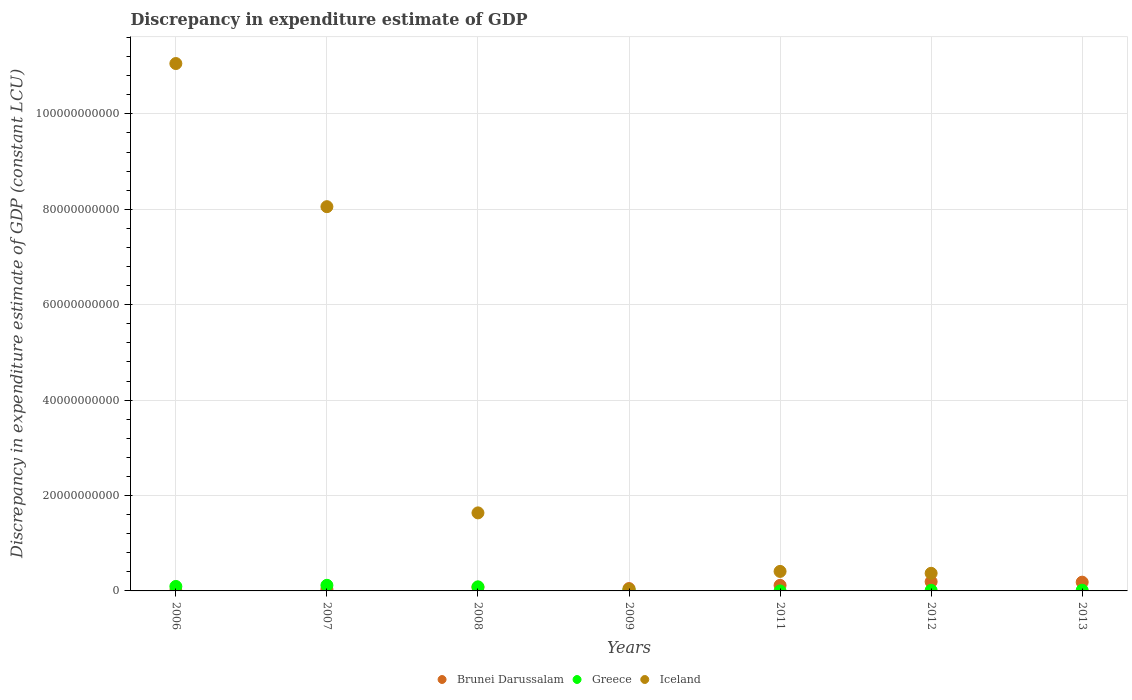What is the discrepancy in expenditure estimate of GDP in Brunei Darussalam in 2013?
Your answer should be very brief. 1.84e+09. Across all years, what is the maximum discrepancy in expenditure estimate of GDP in Iceland?
Offer a very short reply. 1.11e+11. Across all years, what is the minimum discrepancy in expenditure estimate of GDP in Iceland?
Offer a very short reply. 0. In which year was the discrepancy in expenditure estimate of GDP in Greece maximum?
Offer a very short reply. 2007. What is the total discrepancy in expenditure estimate of GDP in Brunei Darussalam in the graph?
Offer a very short reply. 6.58e+09. What is the difference between the discrepancy in expenditure estimate of GDP in Iceland in 2008 and that in 2011?
Provide a succinct answer. 1.23e+1. What is the difference between the discrepancy in expenditure estimate of GDP in Greece in 2007 and the discrepancy in expenditure estimate of GDP in Brunei Darussalam in 2009?
Ensure brevity in your answer.  6.81e+08. What is the average discrepancy in expenditure estimate of GDP in Brunei Darussalam per year?
Provide a short and direct response. 9.40e+08. In the year 2007, what is the difference between the discrepancy in expenditure estimate of GDP in Brunei Darussalam and discrepancy in expenditure estimate of GDP in Iceland?
Your answer should be very brief. -8.02e+1. In how many years, is the discrepancy in expenditure estimate of GDP in Greece greater than 12000000000 LCU?
Ensure brevity in your answer.  0. What is the ratio of the discrepancy in expenditure estimate of GDP in Greece in 2006 to that in 2011?
Give a very brief answer. 1.17e+06. Is the discrepancy in expenditure estimate of GDP in Greece in 2009 less than that in 2012?
Your answer should be compact. No. Is the difference between the discrepancy in expenditure estimate of GDP in Brunei Darussalam in 2009 and 2012 greater than the difference between the discrepancy in expenditure estimate of GDP in Iceland in 2009 and 2012?
Provide a short and direct response. Yes. What is the difference between the highest and the second highest discrepancy in expenditure estimate of GDP in Greece?
Provide a succinct answer. 2.37e+08. What is the difference between the highest and the lowest discrepancy in expenditure estimate of GDP in Greece?
Ensure brevity in your answer.  1.18e+09. In how many years, is the discrepancy in expenditure estimate of GDP in Brunei Darussalam greater than the average discrepancy in expenditure estimate of GDP in Brunei Darussalam taken over all years?
Offer a terse response. 3. Is the sum of the discrepancy in expenditure estimate of GDP in Brunei Darussalam in 2008 and 2011 greater than the maximum discrepancy in expenditure estimate of GDP in Iceland across all years?
Give a very brief answer. No. Does the discrepancy in expenditure estimate of GDP in Greece monotonically increase over the years?
Make the answer very short. No. How many years are there in the graph?
Ensure brevity in your answer.  7. What is the difference between two consecutive major ticks on the Y-axis?
Ensure brevity in your answer.  2.00e+1. Does the graph contain grids?
Your answer should be very brief. Yes. How are the legend labels stacked?
Your answer should be very brief. Horizontal. What is the title of the graph?
Ensure brevity in your answer.  Discrepancy in expenditure estimate of GDP. What is the label or title of the Y-axis?
Your response must be concise. Discrepancy in expenditure estimate of GDP (constant LCU). What is the Discrepancy in expenditure estimate of GDP (constant LCU) of Brunei Darussalam in 2006?
Keep it short and to the point. 3.53e+07. What is the Discrepancy in expenditure estimate of GDP (constant LCU) of Greece in 2006?
Your response must be concise. 9.39e+08. What is the Discrepancy in expenditure estimate of GDP (constant LCU) of Iceland in 2006?
Provide a short and direct response. 1.11e+11. What is the Discrepancy in expenditure estimate of GDP (constant LCU) in Brunei Darussalam in 2007?
Offer a terse response. 3.41e+08. What is the Discrepancy in expenditure estimate of GDP (constant LCU) of Greece in 2007?
Offer a terse response. 1.18e+09. What is the Discrepancy in expenditure estimate of GDP (constant LCU) in Iceland in 2007?
Make the answer very short. 8.05e+1. What is the Discrepancy in expenditure estimate of GDP (constant LCU) in Brunei Darussalam in 2008?
Keep it short and to the point. 7.68e+08. What is the Discrepancy in expenditure estimate of GDP (constant LCU) in Greece in 2008?
Offer a terse response. 8.52e+08. What is the Discrepancy in expenditure estimate of GDP (constant LCU) of Iceland in 2008?
Make the answer very short. 1.64e+1. What is the Discrepancy in expenditure estimate of GDP (constant LCU) of Brunei Darussalam in 2009?
Your response must be concise. 4.96e+08. What is the Discrepancy in expenditure estimate of GDP (constant LCU) in Greece in 2009?
Keep it short and to the point. 2.10e+08. What is the Discrepancy in expenditure estimate of GDP (constant LCU) in Iceland in 2009?
Provide a succinct answer. 3.02e+08. What is the Discrepancy in expenditure estimate of GDP (constant LCU) of Brunei Darussalam in 2011?
Your answer should be very brief. 1.17e+09. What is the Discrepancy in expenditure estimate of GDP (constant LCU) of Greece in 2011?
Your response must be concise. 800. What is the Discrepancy in expenditure estimate of GDP (constant LCU) in Iceland in 2011?
Keep it short and to the point. 4.09e+09. What is the Discrepancy in expenditure estimate of GDP (constant LCU) of Brunei Darussalam in 2012?
Offer a very short reply. 1.93e+09. What is the Discrepancy in expenditure estimate of GDP (constant LCU) in Greece in 2012?
Offer a terse response. 1.22e+08. What is the Discrepancy in expenditure estimate of GDP (constant LCU) of Iceland in 2012?
Your response must be concise. 3.69e+09. What is the Discrepancy in expenditure estimate of GDP (constant LCU) of Brunei Darussalam in 2013?
Offer a very short reply. 1.84e+09. What is the Discrepancy in expenditure estimate of GDP (constant LCU) in Greece in 2013?
Keep it short and to the point. 1.42e+08. What is the Discrepancy in expenditure estimate of GDP (constant LCU) in Iceland in 2013?
Your answer should be compact. 0. Across all years, what is the maximum Discrepancy in expenditure estimate of GDP (constant LCU) of Brunei Darussalam?
Ensure brevity in your answer.  1.93e+09. Across all years, what is the maximum Discrepancy in expenditure estimate of GDP (constant LCU) of Greece?
Provide a succinct answer. 1.18e+09. Across all years, what is the maximum Discrepancy in expenditure estimate of GDP (constant LCU) in Iceland?
Your response must be concise. 1.11e+11. Across all years, what is the minimum Discrepancy in expenditure estimate of GDP (constant LCU) of Brunei Darussalam?
Offer a terse response. 3.53e+07. Across all years, what is the minimum Discrepancy in expenditure estimate of GDP (constant LCU) in Greece?
Keep it short and to the point. 800. Across all years, what is the minimum Discrepancy in expenditure estimate of GDP (constant LCU) of Iceland?
Give a very brief answer. 0. What is the total Discrepancy in expenditure estimate of GDP (constant LCU) in Brunei Darussalam in the graph?
Keep it short and to the point. 6.58e+09. What is the total Discrepancy in expenditure estimate of GDP (constant LCU) in Greece in the graph?
Give a very brief answer. 3.44e+09. What is the total Discrepancy in expenditure estimate of GDP (constant LCU) of Iceland in the graph?
Your response must be concise. 2.16e+11. What is the difference between the Discrepancy in expenditure estimate of GDP (constant LCU) in Brunei Darussalam in 2006 and that in 2007?
Provide a succinct answer. -3.06e+08. What is the difference between the Discrepancy in expenditure estimate of GDP (constant LCU) in Greece in 2006 and that in 2007?
Keep it short and to the point. -2.37e+08. What is the difference between the Discrepancy in expenditure estimate of GDP (constant LCU) in Iceland in 2006 and that in 2007?
Your answer should be compact. 3.00e+1. What is the difference between the Discrepancy in expenditure estimate of GDP (constant LCU) in Brunei Darussalam in 2006 and that in 2008?
Make the answer very short. -7.33e+08. What is the difference between the Discrepancy in expenditure estimate of GDP (constant LCU) in Greece in 2006 and that in 2008?
Ensure brevity in your answer.  8.68e+07. What is the difference between the Discrepancy in expenditure estimate of GDP (constant LCU) of Iceland in 2006 and that in 2008?
Your answer should be compact. 9.42e+1. What is the difference between the Discrepancy in expenditure estimate of GDP (constant LCU) of Brunei Darussalam in 2006 and that in 2009?
Your response must be concise. -4.60e+08. What is the difference between the Discrepancy in expenditure estimate of GDP (constant LCU) in Greece in 2006 and that in 2009?
Give a very brief answer. 7.29e+08. What is the difference between the Discrepancy in expenditure estimate of GDP (constant LCU) of Iceland in 2006 and that in 2009?
Ensure brevity in your answer.  1.10e+11. What is the difference between the Discrepancy in expenditure estimate of GDP (constant LCU) of Brunei Darussalam in 2006 and that in 2011?
Offer a terse response. -1.13e+09. What is the difference between the Discrepancy in expenditure estimate of GDP (constant LCU) of Greece in 2006 and that in 2011?
Keep it short and to the point. 9.39e+08. What is the difference between the Discrepancy in expenditure estimate of GDP (constant LCU) in Iceland in 2006 and that in 2011?
Provide a succinct answer. 1.06e+11. What is the difference between the Discrepancy in expenditure estimate of GDP (constant LCU) in Brunei Darussalam in 2006 and that in 2012?
Ensure brevity in your answer.  -1.90e+09. What is the difference between the Discrepancy in expenditure estimate of GDP (constant LCU) of Greece in 2006 and that in 2012?
Keep it short and to the point. 8.18e+08. What is the difference between the Discrepancy in expenditure estimate of GDP (constant LCU) in Iceland in 2006 and that in 2012?
Keep it short and to the point. 1.07e+11. What is the difference between the Discrepancy in expenditure estimate of GDP (constant LCU) in Brunei Darussalam in 2006 and that in 2013?
Ensure brevity in your answer.  -1.80e+09. What is the difference between the Discrepancy in expenditure estimate of GDP (constant LCU) of Greece in 2006 and that in 2013?
Offer a terse response. 7.97e+08. What is the difference between the Discrepancy in expenditure estimate of GDP (constant LCU) of Brunei Darussalam in 2007 and that in 2008?
Your answer should be very brief. -4.27e+08. What is the difference between the Discrepancy in expenditure estimate of GDP (constant LCU) in Greece in 2007 and that in 2008?
Your response must be concise. 3.24e+08. What is the difference between the Discrepancy in expenditure estimate of GDP (constant LCU) in Iceland in 2007 and that in 2008?
Provide a short and direct response. 6.42e+1. What is the difference between the Discrepancy in expenditure estimate of GDP (constant LCU) of Brunei Darussalam in 2007 and that in 2009?
Your answer should be very brief. -1.55e+08. What is the difference between the Discrepancy in expenditure estimate of GDP (constant LCU) in Greece in 2007 and that in 2009?
Your response must be concise. 9.66e+08. What is the difference between the Discrepancy in expenditure estimate of GDP (constant LCU) in Iceland in 2007 and that in 2009?
Your response must be concise. 8.02e+1. What is the difference between the Discrepancy in expenditure estimate of GDP (constant LCU) of Brunei Darussalam in 2007 and that in 2011?
Make the answer very short. -8.28e+08. What is the difference between the Discrepancy in expenditure estimate of GDP (constant LCU) of Greece in 2007 and that in 2011?
Make the answer very short. 1.18e+09. What is the difference between the Discrepancy in expenditure estimate of GDP (constant LCU) of Iceland in 2007 and that in 2011?
Offer a terse response. 7.65e+1. What is the difference between the Discrepancy in expenditure estimate of GDP (constant LCU) in Brunei Darussalam in 2007 and that in 2012?
Make the answer very short. -1.59e+09. What is the difference between the Discrepancy in expenditure estimate of GDP (constant LCU) in Greece in 2007 and that in 2012?
Make the answer very short. 1.05e+09. What is the difference between the Discrepancy in expenditure estimate of GDP (constant LCU) in Iceland in 2007 and that in 2012?
Offer a terse response. 7.69e+1. What is the difference between the Discrepancy in expenditure estimate of GDP (constant LCU) in Brunei Darussalam in 2007 and that in 2013?
Your answer should be compact. -1.49e+09. What is the difference between the Discrepancy in expenditure estimate of GDP (constant LCU) of Greece in 2007 and that in 2013?
Your answer should be compact. 1.03e+09. What is the difference between the Discrepancy in expenditure estimate of GDP (constant LCU) of Brunei Darussalam in 2008 and that in 2009?
Make the answer very short. 2.72e+08. What is the difference between the Discrepancy in expenditure estimate of GDP (constant LCU) in Greece in 2008 and that in 2009?
Your answer should be very brief. 6.42e+08. What is the difference between the Discrepancy in expenditure estimate of GDP (constant LCU) in Iceland in 2008 and that in 2009?
Provide a short and direct response. 1.61e+1. What is the difference between the Discrepancy in expenditure estimate of GDP (constant LCU) of Brunei Darussalam in 2008 and that in 2011?
Provide a succinct answer. -4.01e+08. What is the difference between the Discrepancy in expenditure estimate of GDP (constant LCU) in Greece in 2008 and that in 2011?
Your answer should be very brief. 8.52e+08. What is the difference between the Discrepancy in expenditure estimate of GDP (constant LCU) in Iceland in 2008 and that in 2011?
Your answer should be compact. 1.23e+1. What is the difference between the Discrepancy in expenditure estimate of GDP (constant LCU) in Brunei Darussalam in 2008 and that in 2012?
Your answer should be very brief. -1.17e+09. What is the difference between the Discrepancy in expenditure estimate of GDP (constant LCU) of Greece in 2008 and that in 2012?
Keep it short and to the point. 7.31e+08. What is the difference between the Discrepancy in expenditure estimate of GDP (constant LCU) in Iceland in 2008 and that in 2012?
Offer a terse response. 1.27e+1. What is the difference between the Discrepancy in expenditure estimate of GDP (constant LCU) in Brunei Darussalam in 2008 and that in 2013?
Provide a short and direct response. -1.07e+09. What is the difference between the Discrepancy in expenditure estimate of GDP (constant LCU) in Greece in 2008 and that in 2013?
Your answer should be compact. 7.10e+08. What is the difference between the Discrepancy in expenditure estimate of GDP (constant LCU) in Brunei Darussalam in 2009 and that in 2011?
Give a very brief answer. -6.73e+08. What is the difference between the Discrepancy in expenditure estimate of GDP (constant LCU) in Greece in 2009 and that in 2011?
Your response must be concise. 2.10e+08. What is the difference between the Discrepancy in expenditure estimate of GDP (constant LCU) in Iceland in 2009 and that in 2011?
Your answer should be very brief. -3.79e+09. What is the difference between the Discrepancy in expenditure estimate of GDP (constant LCU) in Brunei Darussalam in 2009 and that in 2012?
Provide a short and direct response. -1.44e+09. What is the difference between the Discrepancy in expenditure estimate of GDP (constant LCU) in Greece in 2009 and that in 2012?
Your answer should be very brief. 8.82e+07. What is the difference between the Discrepancy in expenditure estimate of GDP (constant LCU) of Iceland in 2009 and that in 2012?
Provide a short and direct response. -3.39e+09. What is the difference between the Discrepancy in expenditure estimate of GDP (constant LCU) in Brunei Darussalam in 2009 and that in 2013?
Ensure brevity in your answer.  -1.34e+09. What is the difference between the Discrepancy in expenditure estimate of GDP (constant LCU) of Greece in 2009 and that in 2013?
Keep it short and to the point. 6.77e+07. What is the difference between the Discrepancy in expenditure estimate of GDP (constant LCU) of Brunei Darussalam in 2011 and that in 2012?
Keep it short and to the point. -7.64e+08. What is the difference between the Discrepancy in expenditure estimate of GDP (constant LCU) in Greece in 2011 and that in 2012?
Ensure brevity in your answer.  -1.22e+08. What is the difference between the Discrepancy in expenditure estimate of GDP (constant LCU) of Iceland in 2011 and that in 2012?
Keep it short and to the point. 3.97e+08. What is the difference between the Discrepancy in expenditure estimate of GDP (constant LCU) in Brunei Darussalam in 2011 and that in 2013?
Offer a very short reply. -6.67e+08. What is the difference between the Discrepancy in expenditure estimate of GDP (constant LCU) of Greece in 2011 and that in 2013?
Your answer should be very brief. -1.42e+08. What is the difference between the Discrepancy in expenditure estimate of GDP (constant LCU) in Brunei Darussalam in 2012 and that in 2013?
Your answer should be very brief. 9.79e+07. What is the difference between the Discrepancy in expenditure estimate of GDP (constant LCU) in Greece in 2012 and that in 2013?
Your answer should be very brief. -2.05e+07. What is the difference between the Discrepancy in expenditure estimate of GDP (constant LCU) of Brunei Darussalam in 2006 and the Discrepancy in expenditure estimate of GDP (constant LCU) of Greece in 2007?
Provide a short and direct response. -1.14e+09. What is the difference between the Discrepancy in expenditure estimate of GDP (constant LCU) in Brunei Darussalam in 2006 and the Discrepancy in expenditure estimate of GDP (constant LCU) in Iceland in 2007?
Give a very brief answer. -8.05e+1. What is the difference between the Discrepancy in expenditure estimate of GDP (constant LCU) in Greece in 2006 and the Discrepancy in expenditure estimate of GDP (constant LCU) in Iceland in 2007?
Ensure brevity in your answer.  -7.96e+1. What is the difference between the Discrepancy in expenditure estimate of GDP (constant LCU) of Brunei Darussalam in 2006 and the Discrepancy in expenditure estimate of GDP (constant LCU) of Greece in 2008?
Keep it short and to the point. -8.17e+08. What is the difference between the Discrepancy in expenditure estimate of GDP (constant LCU) in Brunei Darussalam in 2006 and the Discrepancy in expenditure estimate of GDP (constant LCU) in Iceland in 2008?
Offer a very short reply. -1.63e+1. What is the difference between the Discrepancy in expenditure estimate of GDP (constant LCU) of Greece in 2006 and the Discrepancy in expenditure estimate of GDP (constant LCU) of Iceland in 2008?
Offer a very short reply. -1.54e+1. What is the difference between the Discrepancy in expenditure estimate of GDP (constant LCU) in Brunei Darussalam in 2006 and the Discrepancy in expenditure estimate of GDP (constant LCU) in Greece in 2009?
Ensure brevity in your answer.  -1.75e+08. What is the difference between the Discrepancy in expenditure estimate of GDP (constant LCU) of Brunei Darussalam in 2006 and the Discrepancy in expenditure estimate of GDP (constant LCU) of Iceland in 2009?
Your answer should be very brief. -2.67e+08. What is the difference between the Discrepancy in expenditure estimate of GDP (constant LCU) of Greece in 2006 and the Discrepancy in expenditure estimate of GDP (constant LCU) of Iceland in 2009?
Offer a terse response. 6.37e+08. What is the difference between the Discrepancy in expenditure estimate of GDP (constant LCU) of Brunei Darussalam in 2006 and the Discrepancy in expenditure estimate of GDP (constant LCU) of Greece in 2011?
Offer a very short reply. 3.53e+07. What is the difference between the Discrepancy in expenditure estimate of GDP (constant LCU) in Brunei Darussalam in 2006 and the Discrepancy in expenditure estimate of GDP (constant LCU) in Iceland in 2011?
Ensure brevity in your answer.  -4.05e+09. What is the difference between the Discrepancy in expenditure estimate of GDP (constant LCU) in Greece in 2006 and the Discrepancy in expenditure estimate of GDP (constant LCU) in Iceland in 2011?
Provide a succinct answer. -3.15e+09. What is the difference between the Discrepancy in expenditure estimate of GDP (constant LCU) in Brunei Darussalam in 2006 and the Discrepancy in expenditure estimate of GDP (constant LCU) in Greece in 2012?
Ensure brevity in your answer.  -8.65e+07. What is the difference between the Discrepancy in expenditure estimate of GDP (constant LCU) of Brunei Darussalam in 2006 and the Discrepancy in expenditure estimate of GDP (constant LCU) of Iceland in 2012?
Give a very brief answer. -3.66e+09. What is the difference between the Discrepancy in expenditure estimate of GDP (constant LCU) of Greece in 2006 and the Discrepancy in expenditure estimate of GDP (constant LCU) of Iceland in 2012?
Your answer should be compact. -2.75e+09. What is the difference between the Discrepancy in expenditure estimate of GDP (constant LCU) in Brunei Darussalam in 2006 and the Discrepancy in expenditure estimate of GDP (constant LCU) in Greece in 2013?
Provide a short and direct response. -1.07e+08. What is the difference between the Discrepancy in expenditure estimate of GDP (constant LCU) of Brunei Darussalam in 2007 and the Discrepancy in expenditure estimate of GDP (constant LCU) of Greece in 2008?
Offer a terse response. -5.12e+08. What is the difference between the Discrepancy in expenditure estimate of GDP (constant LCU) of Brunei Darussalam in 2007 and the Discrepancy in expenditure estimate of GDP (constant LCU) of Iceland in 2008?
Give a very brief answer. -1.60e+1. What is the difference between the Discrepancy in expenditure estimate of GDP (constant LCU) of Greece in 2007 and the Discrepancy in expenditure estimate of GDP (constant LCU) of Iceland in 2008?
Provide a succinct answer. -1.52e+1. What is the difference between the Discrepancy in expenditure estimate of GDP (constant LCU) in Brunei Darussalam in 2007 and the Discrepancy in expenditure estimate of GDP (constant LCU) in Greece in 2009?
Offer a very short reply. 1.31e+08. What is the difference between the Discrepancy in expenditure estimate of GDP (constant LCU) in Brunei Darussalam in 2007 and the Discrepancy in expenditure estimate of GDP (constant LCU) in Iceland in 2009?
Offer a terse response. 3.87e+07. What is the difference between the Discrepancy in expenditure estimate of GDP (constant LCU) of Greece in 2007 and the Discrepancy in expenditure estimate of GDP (constant LCU) of Iceland in 2009?
Offer a very short reply. 8.74e+08. What is the difference between the Discrepancy in expenditure estimate of GDP (constant LCU) of Brunei Darussalam in 2007 and the Discrepancy in expenditure estimate of GDP (constant LCU) of Greece in 2011?
Keep it short and to the point. 3.41e+08. What is the difference between the Discrepancy in expenditure estimate of GDP (constant LCU) of Brunei Darussalam in 2007 and the Discrepancy in expenditure estimate of GDP (constant LCU) of Iceland in 2011?
Keep it short and to the point. -3.75e+09. What is the difference between the Discrepancy in expenditure estimate of GDP (constant LCU) in Greece in 2007 and the Discrepancy in expenditure estimate of GDP (constant LCU) in Iceland in 2011?
Offer a very short reply. -2.91e+09. What is the difference between the Discrepancy in expenditure estimate of GDP (constant LCU) in Brunei Darussalam in 2007 and the Discrepancy in expenditure estimate of GDP (constant LCU) in Greece in 2012?
Provide a succinct answer. 2.19e+08. What is the difference between the Discrepancy in expenditure estimate of GDP (constant LCU) in Brunei Darussalam in 2007 and the Discrepancy in expenditure estimate of GDP (constant LCU) in Iceland in 2012?
Keep it short and to the point. -3.35e+09. What is the difference between the Discrepancy in expenditure estimate of GDP (constant LCU) in Greece in 2007 and the Discrepancy in expenditure estimate of GDP (constant LCU) in Iceland in 2012?
Offer a very short reply. -2.52e+09. What is the difference between the Discrepancy in expenditure estimate of GDP (constant LCU) in Brunei Darussalam in 2007 and the Discrepancy in expenditure estimate of GDP (constant LCU) in Greece in 2013?
Provide a succinct answer. 1.98e+08. What is the difference between the Discrepancy in expenditure estimate of GDP (constant LCU) of Brunei Darussalam in 2008 and the Discrepancy in expenditure estimate of GDP (constant LCU) of Greece in 2009?
Provide a short and direct response. 5.58e+08. What is the difference between the Discrepancy in expenditure estimate of GDP (constant LCU) of Brunei Darussalam in 2008 and the Discrepancy in expenditure estimate of GDP (constant LCU) of Iceland in 2009?
Provide a succinct answer. 4.66e+08. What is the difference between the Discrepancy in expenditure estimate of GDP (constant LCU) of Greece in 2008 and the Discrepancy in expenditure estimate of GDP (constant LCU) of Iceland in 2009?
Keep it short and to the point. 5.50e+08. What is the difference between the Discrepancy in expenditure estimate of GDP (constant LCU) of Brunei Darussalam in 2008 and the Discrepancy in expenditure estimate of GDP (constant LCU) of Greece in 2011?
Offer a very short reply. 7.68e+08. What is the difference between the Discrepancy in expenditure estimate of GDP (constant LCU) in Brunei Darussalam in 2008 and the Discrepancy in expenditure estimate of GDP (constant LCU) in Iceland in 2011?
Keep it short and to the point. -3.32e+09. What is the difference between the Discrepancy in expenditure estimate of GDP (constant LCU) of Greece in 2008 and the Discrepancy in expenditure estimate of GDP (constant LCU) of Iceland in 2011?
Your answer should be compact. -3.24e+09. What is the difference between the Discrepancy in expenditure estimate of GDP (constant LCU) of Brunei Darussalam in 2008 and the Discrepancy in expenditure estimate of GDP (constant LCU) of Greece in 2012?
Offer a very short reply. 6.46e+08. What is the difference between the Discrepancy in expenditure estimate of GDP (constant LCU) in Brunei Darussalam in 2008 and the Discrepancy in expenditure estimate of GDP (constant LCU) in Iceland in 2012?
Ensure brevity in your answer.  -2.93e+09. What is the difference between the Discrepancy in expenditure estimate of GDP (constant LCU) in Greece in 2008 and the Discrepancy in expenditure estimate of GDP (constant LCU) in Iceland in 2012?
Make the answer very short. -2.84e+09. What is the difference between the Discrepancy in expenditure estimate of GDP (constant LCU) of Brunei Darussalam in 2008 and the Discrepancy in expenditure estimate of GDP (constant LCU) of Greece in 2013?
Provide a succinct answer. 6.26e+08. What is the difference between the Discrepancy in expenditure estimate of GDP (constant LCU) of Brunei Darussalam in 2009 and the Discrepancy in expenditure estimate of GDP (constant LCU) of Greece in 2011?
Make the answer very short. 4.95e+08. What is the difference between the Discrepancy in expenditure estimate of GDP (constant LCU) of Brunei Darussalam in 2009 and the Discrepancy in expenditure estimate of GDP (constant LCU) of Iceland in 2011?
Your response must be concise. -3.59e+09. What is the difference between the Discrepancy in expenditure estimate of GDP (constant LCU) in Greece in 2009 and the Discrepancy in expenditure estimate of GDP (constant LCU) in Iceland in 2011?
Provide a succinct answer. -3.88e+09. What is the difference between the Discrepancy in expenditure estimate of GDP (constant LCU) in Brunei Darussalam in 2009 and the Discrepancy in expenditure estimate of GDP (constant LCU) in Greece in 2012?
Ensure brevity in your answer.  3.74e+08. What is the difference between the Discrepancy in expenditure estimate of GDP (constant LCU) in Brunei Darussalam in 2009 and the Discrepancy in expenditure estimate of GDP (constant LCU) in Iceland in 2012?
Provide a succinct answer. -3.20e+09. What is the difference between the Discrepancy in expenditure estimate of GDP (constant LCU) in Greece in 2009 and the Discrepancy in expenditure estimate of GDP (constant LCU) in Iceland in 2012?
Give a very brief answer. -3.48e+09. What is the difference between the Discrepancy in expenditure estimate of GDP (constant LCU) in Brunei Darussalam in 2009 and the Discrepancy in expenditure estimate of GDP (constant LCU) in Greece in 2013?
Provide a short and direct response. 3.53e+08. What is the difference between the Discrepancy in expenditure estimate of GDP (constant LCU) of Brunei Darussalam in 2011 and the Discrepancy in expenditure estimate of GDP (constant LCU) of Greece in 2012?
Ensure brevity in your answer.  1.05e+09. What is the difference between the Discrepancy in expenditure estimate of GDP (constant LCU) of Brunei Darussalam in 2011 and the Discrepancy in expenditure estimate of GDP (constant LCU) of Iceland in 2012?
Provide a short and direct response. -2.52e+09. What is the difference between the Discrepancy in expenditure estimate of GDP (constant LCU) in Greece in 2011 and the Discrepancy in expenditure estimate of GDP (constant LCU) in Iceland in 2012?
Your answer should be very brief. -3.69e+09. What is the difference between the Discrepancy in expenditure estimate of GDP (constant LCU) in Brunei Darussalam in 2011 and the Discrepancy in expenditure estimate of GDP (constant LCU) in Greece in 2013?
Your answer should be very brief. 1.03e+09. What is the difference between the Discrepancy in expenditure estimate of GDP (constant LCU) of Brunei Darussalam in 2012 and the Discrepancy in expenditure estimate of GDP (constant LCU) of Greece in 2013?
Your answer should be compact. 1.79e+09. What is the average Discrepancy in expenditure estimate of GDP (constant LCU) of Brunei Darussalam per year?
Your answer should be compact. 9.40e+08. What is the average Discrepancy in expenditure estimate of GDP (constant LCU) in Greece per year?
Give a very brief answer. 4.92e+08. What is the average Discrepancy in expenditure estimate of GDP (constant LCU) of Iceland per year?
Make the answer very short. 3.08e+1. In the year 2006, what is the difference between the Discrepancy in expenditure estimate of GDP (constant LCU) in Brunei Darussalam and Discrepancy in expenditure estimate of GDP (constant LCU) in Greece?
Ensure brevity in your answer.  -9.04e+08. In the year 2006, what is the difference between the Discrepancy in expenditure estimate of GDP (constant LCU) in Brunei Darussalam and Discrepancy in expenditure estimate of GDP (constant LCU) in Iceland?
Ensure brevity in your answer.  -1.11e+11. In the year 2006, what is the difference between the Discrepancy in expenditure estimate of GDP (constant LCU) in Greece and Discrepancy in expenditure estimate of GDP (constant LCU) in Iceland?
Ensure brevity in your answer.  -1.10e+11. In the year 2007, what is the difference between the Discrepancy in expenditure estimate of GDP (constant LCU) in Brunei Darussalam and Discrepancy in expenditure estimate of GDP (constant LCU) in Greece?
Make the answer very short. -8.35e+08. In the year 2007, what is the difference between the Discrepancy in expenditure estimate of GDP (constant LCU) of Brunei Darussalam and Discrepancy in expenditure estimate of GDP (constant LCU) of Iceland?
Your answer should be very brief. -8.02e+1. In the year 2007, what is the difference between the Discrepancy in expenditure estimate of GDP (constant LCU) in Greece and Discrepancy in expenditure estimate of GDP (constant LCU) in Iceland?
Your response must be concise. -7.94e+1. In the year 2008, what is the difference between the Discrepancy in expenditure estimate of GDP (constant LCU) in Brunei Darussalam and Discrepancy in expenditure estimate of GDP (constant LCU) in Greece?
Give a very brief answer. -8.45e+07. In the year 2008, what is the difference between the Discrepancy in expenditure estimate of GDP (constant LCU) of Brunei Darussalam and Discrepancy in expenditure estimate of GDP (constant LCU) of Iceland?
Your answer should be compact. -1.56e+1. In the year 2008, what is the difference between the Discrepancy in expenditure estimate of GDP (constant LCU) of Greece and Discrepancy in expenditure estimate of GDP (constant LCU) of Iceland?
Offer a very short reply. -1.55e+1. In the year 2009, what is the difference between the Discrepancy in expenditure estimate of GDP (constant LCU) in Brunei Darussalam and Discrepancy in expenditure estimate of GDP (constant LCU) in Greece?
Keep it short and to the point. 2.85e+08. In the year 2009, what is the difference between the Discrepancy in expenditure estimate of GDP (constant LCU) in Brunei Darussalam and Discrepancy in expenditure estimate of GDP (constant LCU) in Iceland?
Make the answer very short. 1.93e+08. In the year 2009, what is the difference between the Discrepancy in expenditure estimate of GDP (constant LCU) in Greece and Discrepancy in expenditure estimate of GDP (constant LCU) in Iceland?
Provide a short and direct response. -9.21e+07. In the year 2011, what is the difference between the Discrepancy in expenditure estimate of GDP (constant LCU) in Brunei Darussalam and Discrepancy in expenditure estimate of GDP (constant LCU) in Greece?
Your response must be concise. 1.17e+09. In the year 2011, what is the difference between the Discrepancy in expenditure estimate of GDP (constant LCU) of Brunei Darussalam and Discrepancy in expenditure estimate of GDP (constant LCU) of Iceland?
Offer a terse response. -2.92e+09. In the year 2011, what is the difference between the Discrepancy in expenditure estimate of GDP (constant LCU) in Greece and Discrepancy in expenditure estimate of GDP (constant LCU) in Iceland?
Provide a short and direct response. -4.09e+09. In the year 2012, what is the difference between the Discrepancy in expenditure estimate of GDP (constant LCU) in Brunei Darussalam and Discrepancy in expenditure estimate of GDP (constant LCU) in Greece?
Keep it short and to the point. 1.81e+09. In the year 2012, what is the difference between the Discrepancy in expenditure estimate of GDP (constant LCU) in Brunei Darussalam and Discrepancy in expenditure estimate of GDP (constant LCU) in Iceland?
Give a very brief answer. -1.76e+09. In the year 2012, what is the difference between the Discrepancy in expenditure estimate of GDP (constant LCU) of Greece and Discrepancy in expenditure estimate of GDP (constant LCU) of Iceland?
Offer a terse response. -3.57e+09. In the year 2013, what is the difference between the Discrepancy in expenditure estimate of GDP (constant LCU) in Brunei Darussalam and Discrepancy in expenditure estimate of GDP (constant LCU) in Greece?
Your answer should be very brief. 1.69e+09. What is the ratio of the Discrepancy in expenditure estimate of GDP (constant LCU) in Brunei Darussalam in 2006 to that in 2007?
Provide a succinct answer. 0.1. What is the ratio of the Discrepancy in expenditure estimate of GDP (constant LCU) of Greece in 2006 to that in 2007?
Your answer should be very brief. 0.8. What is the ratio of the Discrepancy in expenditure estimate of GDP (constant LCU) of Iceland in 2006 to that in 2007?
Offer a terse response. 1.37. What is the ratio of the Discrepancy in expenditure estimate of GDP (constant LCU) in Brunei Darussalam in 2006 to that in 2008?
Your response must be concise. 0.05. What is the ratio of the Discrepancy in expenditure estimate of GDP (constant LCU) of Greece in 2006 to that in 2008?
Your answer should be compact. 1.1. What is the ratio of the Discrepancy in expenditure estimate of GDP (constant LCU) in Iceland in 2006 to that in 2008?
Provide a short and direct response. 6.76. What is the ratio of the Discrepancy in expenditure estimate of GDP (constant LCU) of Brunei Darussalam in 2006 to that in 2009?
Offer a terse response. 0.07. What is the ratio of the Discrepancy in expenditure estimate of GDP (constant LCU) of Greece in 2006 to that in 2009?
Your response must be concise. 4.47. What is the ratio of the Discrepancy in expenditure estimate of GDP (constant LCU) in Iceland in 2006 to that in 2009?
Your response must be concise. 365.89. What is the ratio of the Discrepancy in expenditure estimate of GDP (constant LCU) in Brunei Darussalam in 2006 to that in 2011?
Your answer should be very brief. 0.03. What is the ratio of the Discrepancy in expenditure estimate of GDP (constant LCU) of Greece in 2006 to that in 2011?
Offer a very short reply. 1.17e+06. What is the ratio of the Discrepancy in expenditure estimate of GDP (constant LCU) in Iceland in 2006 to that in 2011?
Make the answer very short. 27.03. What is the ratio of the Discrepancy in expenditure estimate of GDP (constant LCU) in Brunei Darussalam in 2006 to that in 2012?
Your response must be concise. 0.02. What is the ratio of the Discrepancy in expenditure estimate of GDP (constant LCU) of Greece in 2006 to that in 2012?
Your response must be concise. 7.71. What is the ratio of the Discrepancy in expenditure estimate of GDP (constant LCU) of Iceland in 2006 to that in 2012?
Offer a very short reply. 29.93. What is the ratio of the Discrepancy in expenditure estimate of GDP (constant LCU) of Brunei Darussalam in 2006 to that in 2013?
Offer a terse response. 0.02. What is the ratio of the Discrepancy in expenditure estimate of GDP (constant LCU) in Greece in 2006 to that in 2013?
Keep it short and to the point. 6.6. What is the ratio of the Discrepancy in expenditure estimate of GDP (constant LCU) of Brunei Darussalam in 2007 to that in 2008?
Your answer should be compact. 0.44. What is the ratio of the Discrepancy in expenditure estimate of GDP (constant LCU) in Greece in 2007 to that in 2008?
Your response must be concise. 1.38. What is the ratio of the Discrepancy in expenditure estimate of GDP (constant LCU) of Iceland in 2007 to that in 2008?
Provide a short and direct response. 4.92. What is the ratio of the Discrepancy in expenditure estimate of GDP (constant LCU) of Brunei Darussalam in 2007 to that in 2009?
Offer a very short reply. 0.69. What is the ratio of the Discrepancy in expenditure estimate of GDP (constant LCU) of Greece in 2007 to that in 2009?
Your response must be concise. 5.6. What is the ratio of the Discrepancy in expenditure estimate of GDP (constant LCU) in Iceland in 2007 to that in 2009?
Offer a terse response. 266.59. What is the ratio of the Discrepancy in expenditure estimate of GDP (constant LCU) in Brunei Darussalam in 2007 to that in 2011?
Keep it short and to the point. 0.29. What is the ratio of the Discrepancy in expenditure estimate of GDP (constant LCU) in Greece in 2007 to that in 2011?
Offer a terse response. 1.47e+06. What is the ratio of the Discrepancy in expenditure estimate of GDP (constant LCU) in Iceland in 2007 to that in 2011?
Keep it short and to the point. 19.69. What is the ratio of the Discrepancy in expenditure estimate of GDP (constant LCU) in Brunei Darussalam in 2007 to that in 2012?
Your answer should be compact. 0.18. What is the ratio of the Discrepancy in expenditure estimate of GDP (constant LCU) of Greece in 2007 to that in 2012?
Ensure brevity in your answer.  9.66. What is the ratio of the Discrepancy in expenditure estimate of GDP (constant LCU) in Iceland in 2007 to that in 2012?
Your answer should be compact. 21.81. What is the ratio of the Discrepancy in expenditure estimate of GDP (constant LCU) of Brunei Darussalam in 2007 to that in 2013?
Ensure brevity in your answer.  0.19. What is the ratio of the Discrepancy in expenditure estimate of GDP (constant LCU) of Greece in 2007 to that in 2013?
Offer a terse response. 8.26. What is the ratio of the Discrepancy in expenditure estimate of GDP (constant LCU) of Brunei Darussalam in 2008 to that in 2009?
Provide a succinct answer. 1.55. What is the ratio of the Discrepancy in expenditure estimate of GDP (constant LCU) in Greece in 2008 to that in 2009?
Your response must be concise. 4.06. What is the ratio of the Discrepancy in expenditure estimate of GDP (constant LCU) of Iceland in 2008 to that in 2009?
Keep it short and to the point. 54.14. What is the ratio of the Discrepancy in expenditure estimate of GDP (constant LCU) in Brunei Darussalam in 2008 to that in 2011?
Your answer should be compact. 0.66. What is the ratio of the Discrepancy in expenditure estimate of GDP (constant LCU) of Greece in 2008 to that in 2011?
Your answer should be very brief. 1.07e+06. What is the ratio of the Discrepancy in expenditure estimate of GDP (constant LCU) of Iceland in 2008 to that in 2011?
Your answer should be very brief. 4. What is the ratio of the Discrepancy in expenditure estimate of GDP (constant LCU) in Brunei Darussalam in 2008 to that in 2012?
Your answer should be compact. 0.4. What is the ratio of the Discrepancy in expenditure estimate of GDP (constant LCU) in Greece in 2008 to that in 2012?
Your answer should be very brief. 7. What is the ratio of the Discrepancy in expenditure estimate of GDP (constant LCU) in Iceland in 2008 to that in 2012?
Make the answer very short. 4.43. What is the ratio of the Discrepancy in expenditure estimate of GDP (constant LCU) in Brunei Darussalam in 2008 to that in 2013?
Your response must be concise. 0.42. What is the ratio of the Discrepancy in expenditure estimate of GDP (constant LCU) of Greece in 2008 to that in 2013?
Offer a terse response. 5.99. What is the ratio of the Discrepancy in expenditure estimate of GDP (constant LCU) in Brunei Darussalam in 2009 to that in 2011?
Your answer should be compact. 0.42. What is the ratio of the Discrepancy in expenditure estimate of GDP (constant LCU) of Greece in 2009 to that in 2011?
Provide a short and direct response. 2.63e+05. What is the ratio of the Discrepancy in expenditure estimate of GDP (constant LCU) in Iceland in 2009 to that in 2011?
Provide a succinct answer. 0.07. What is the ratio of the Discrepancy in expenditure estimate of GDP (constant LCU) of Brunei Darussalam in 2009 to that in 2012?
Keep it short and to the point. 0.26. What is the ratio of the Discrepancy in expenditure estimate of GDP (constant LCU) of Greece in 2009 to that in 2012?
Offer a terse response. 1.72. What is the ratio of the Discrepancy in expenditure estimate of GDP (constant LCU) of Iceland in 2009 to that in 2012?
Your answer should be very brief. 0.08. What is the ratio of the Discrepancy in expenditure estimate of GDP (constant LCU) in Brunei Darussalam in 2009 to that in 2013?
Provide a short and direct response. 0.27. What is the ratio of the Discrepancy in expenditure estimate of GDP (constant LCU) in Greece in 2009 to that in 2013?
Make the answer very short. 1.48. What is the ratio of the Discrepancy in expenditure estimate of GDP (constant LCU) in Brunei Darussalam in 2011 to that in 2012?
Keep it short and to the point. 0.6. What is the ratio of the Discrepancy in expenditure estimate of GDP (constant LCU) of Greece in 2011 to that in 2012?
Give a very brief answer. 0. What is the ratio of the Discrepancy in expenditure estimate of GDP (constant LCU) of Iceland in 2011 to that in 2012?
Make the answer very short. 1.11. What is the ratio of the Discrepancy in expenditure estimate of GDP (constant LCU) in Brunei Darussalam in 2011 to that in 2013?
Make the answer very short. 0.64. What is the ratio of the Discrepancy in expenditure estimate of GDP (constant LCU) in Greece in 2011 to that in 2013?
Your response must be concise. 0. What is the ratio of the Discrepancy in expenditure estimate of GDP (constant LCU) in Brunei Darussalam in 2012 to that in 2013?
Your answer should be compact. 1.05. What is the ratio of the Discrepancy in expenditure estimate of GDP (constant LCU) in Greece in 2012 to that in 2013?
Provide a succinct answer. 0.86. What is the difference between the highest and the second highest Discrepancy in expenditure estimate of GDP (constant LCU) of Brunei Darussalam?
Provide a short and direct response. 9.79e+07. What is the difference between the highest and the second highest Discrepancy in expenditure estimate of GDP (constant LCU) of Greece?
Your answer should be very brief. 2.37e+08. What is the difference between the highest and the second highest Discrepancy in expenditure estimate of GDP (constant LCU) of Iceland?
Provide a short and direct response. 3.00e+1. What is the difference between the highest and the lowest Discrepancy in expenditure estimate of GDP (constant LCU) in Brunei Darussalam?
Make the answer very short. 1.90e+09. What is the difference between the highest and the lowest Discrepancy in expenditure estimate of GDP (constant LCU) of Greece?
Your response must be concise. 1.18e+09. What is the difference between the highest and the lowest Discrepancy in expenditure estimate of GDP (constant LCU) in Iceland?
Make the answer very short. 1.11e+11. 